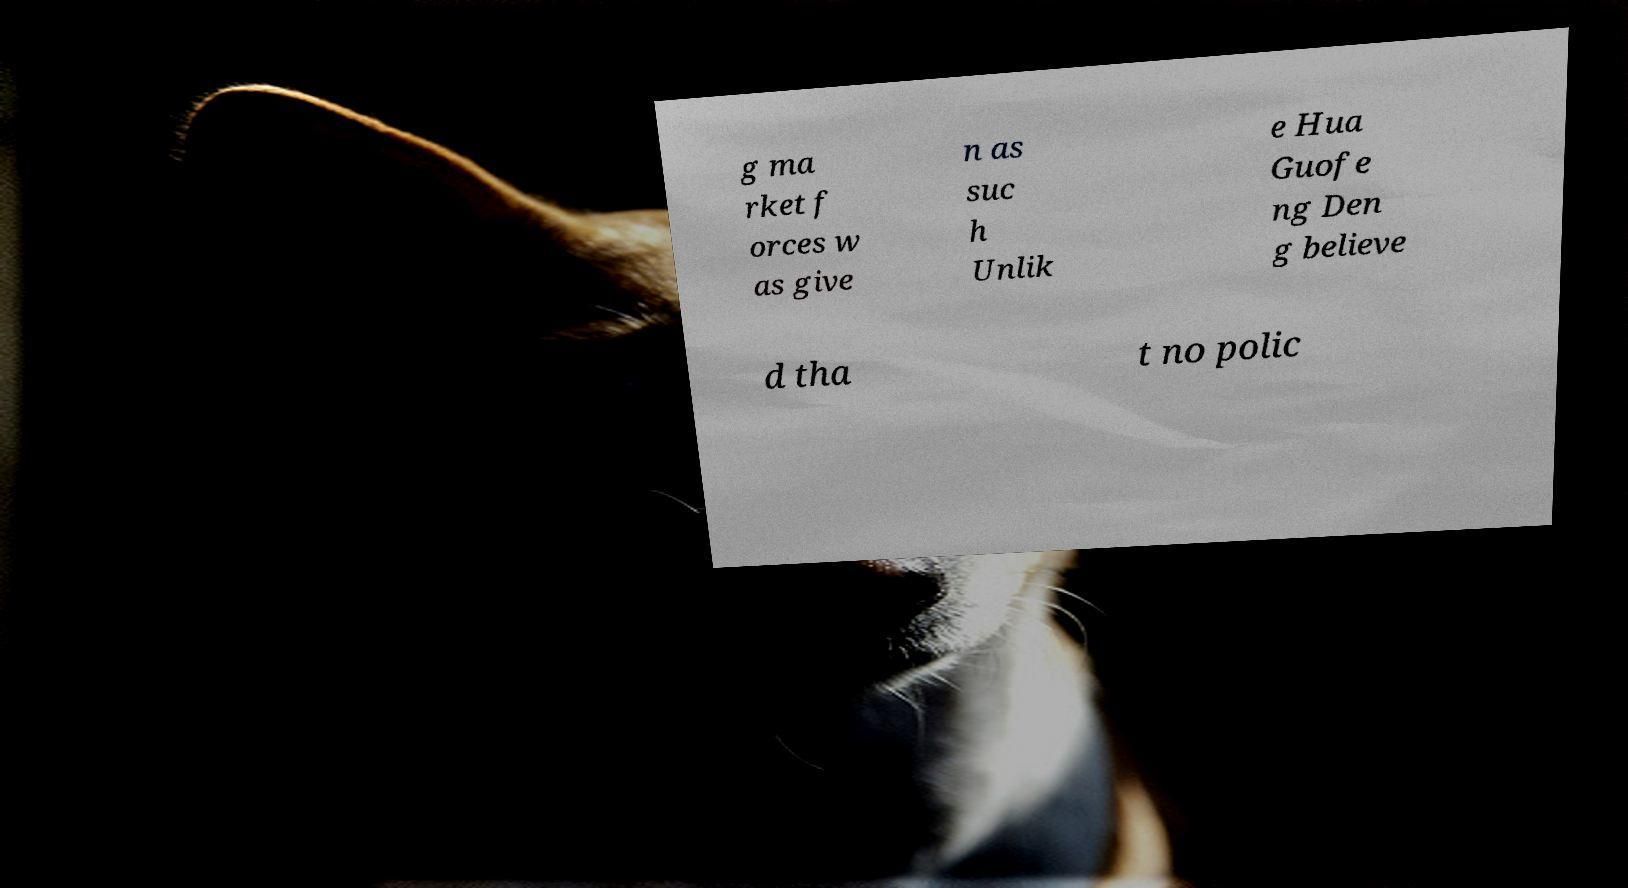Can you accurately transcribe the text from the provided image for me? g ma rket f orces w as give n as suc h Unlik e Hua Guofe ng Den g believe d tha t no polic 